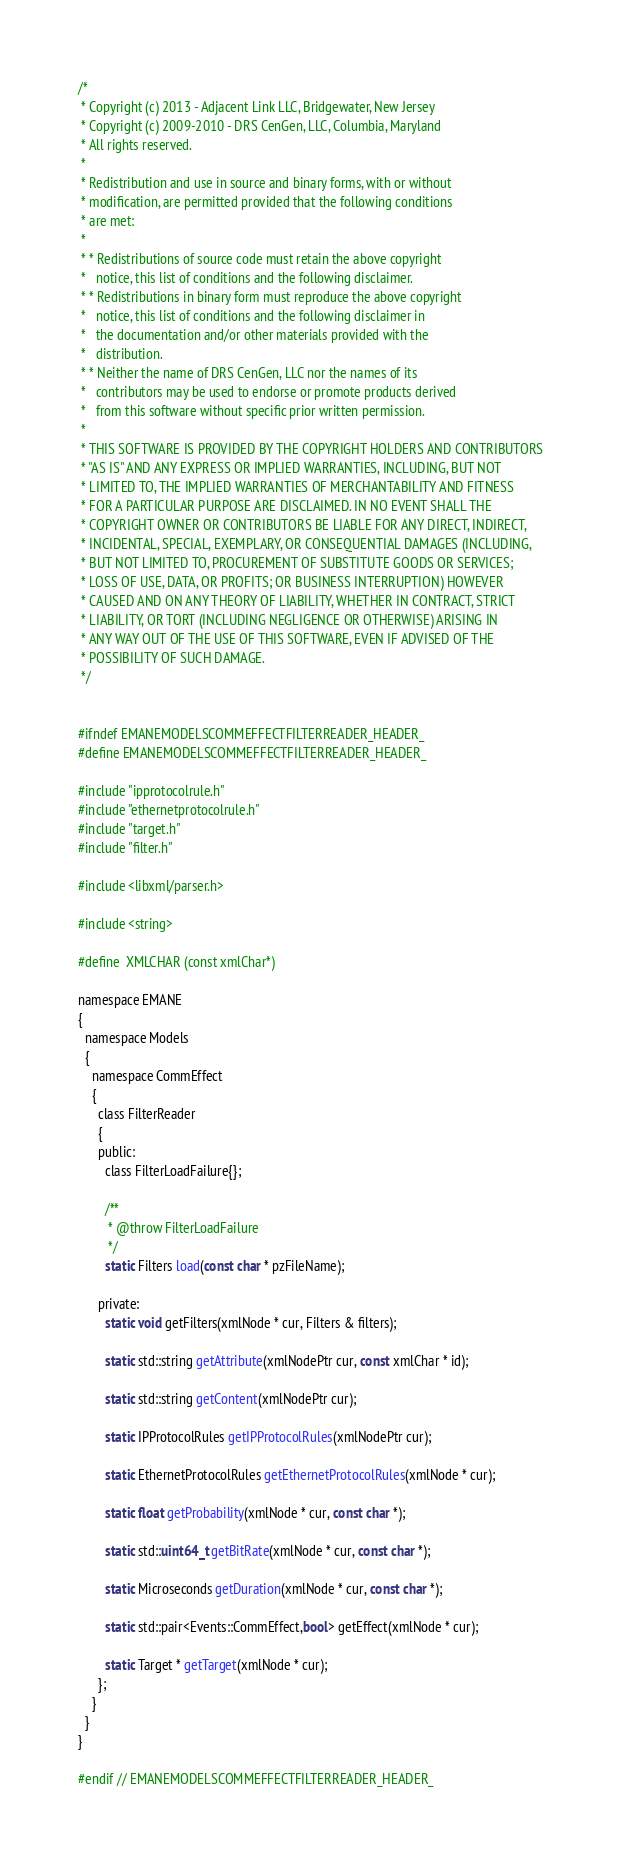<code> <loc_0><loc_0><loc_500><loc_500><_C_>/*
 * Copyright (c) 2013 - Adjacent Link LLC, Bridgewater, New Jersey
 * Copyright (c) 2009-2010 - DRS CenGen, LLC, Columbia, Maryland
 * All rights reserved.
 *
 * Redistribution and use in source and binary forms, with or without
 * modification, are permitted provided that the following conditions
 * are met:
 *
 * * Redistributions of source code must retain the above copyright
 *   notice, this list of conditions and the following disclaimer.
 * * Redistributions in binary form must reproduce the above copyright
 *   notice, this list of conditions and the following disclaimer in
 *   the documentation and/or other materials provided with the
 *   distribution.
 * * Neither the name of DRS CenGen, LLC nor the names of its
 *   contributors may be used to endorse or promote products derived
 *   from this software without specific prior written permission.
 *
 * THIS SOFTWARE IS PROVIDED BY THE COPYRIGHT HOLDERS AND CONTRIBUTORS
 * "AS IS" AND ANY EXPRESS OR IMPLIED WARRANTIES, INCLUDING, BUT NOT
 * LIMITED TO, THE IMPLIED WARRANTIES OF MERCHANTABILITY AND FITNESS
 * FOR A PARTICULAR PURPOSE ARE DISCLAIMED. IN NO EVENT SHALL THE
 * COPYRIGHT OWNER OR CONTRIBUTORS BE LIABLE FOR ANY DIRECT, INDIRECT,
 * INCIDENTAL, SPECIAL, EXEMPLARY, OR CONSEQUENTIAL DAMAGES (INCLUDING,
 * BUT NOT LIMITED TO, PROCUREMENT OF SUBSTITUTE GOODS OR SERVICES;
 * LOSS OF USE, DATA, OR PROFITS; OR BUSINESS INTERRUPTION) HOWEVER
 * CAUSED AND ON ANY THEORY OF LIABILITY, WHETHER IN CONTRACT, STRICT
 * LIABILITY, OR TORT (INCLUDING NEGLIGENCE OR OTHERWISE) ARISING IN
 * ANY WAY OUT OF THE USE OF THIS SOFTWARE, EVEN IF ADVISED OF THE
 * POSSIBILITY OF SUCH DAMAGE.
 */


#ifndef EMANEMODELSCOMMEFFECTFILTERREADER_HEADER_
#define EMANEMODELSCOMMEFFECTFILTERREADER_HEADER_

#include "ipprotocolrule.h"
#include "ethernetprotocolrule.h"
#include "target.h"
#include "filter.h"

#include <libxml/parser.h>

#include <string>

#define  XMLCHAR (const xmlChar*)

namespace EMANE
{
  namespace Models
  {
    namespace CommEffect
    {
      class FilterReader
      {
      public:
        class FilterLoadFailure{};

        /**
         * @throw FilterLoadFailure
         */
        static Filters load(const char * pzFileName);
      
      private:
        static void getFilters(xmlNode * cur, Filters & filters);
      
        static std::string getAttribute(xmlNodePtr cur, const xmlChar * id);
      
        static std::string getContent(xmlNodePtr cur);
      
        static IPProtocolRules getIPProtocolRules(xmlNodePtr cur);
      
        static EthernetProtocolRules getEthernetProtocolRules(xmlNode * cur);
      
        static float getProbability(xmlNode * cur, const char *);
      
        static std::uint64_t getBitRate(xmlNode * cur, const char *);
      
        static Microseconds getDuration(xmlNode * cur, const char *);
      
        static std::pair<Events::CommEffect,bool> getEffect(xmlNode * cur);
      
        static Target * getTarget(xmlNode * cur);
      };
    }
  }
}

#endif // EMANEMODELSCOMMEFFECTFILTERREADER_HEADER_
</code> 